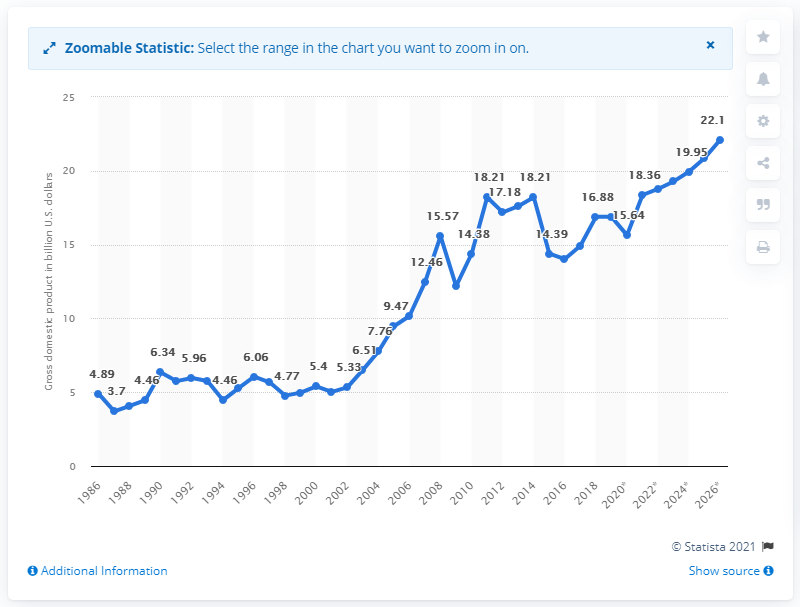Highlight a few significant elements in this photo. The gross domestic product of Gabon in 2019 was 16.88. 